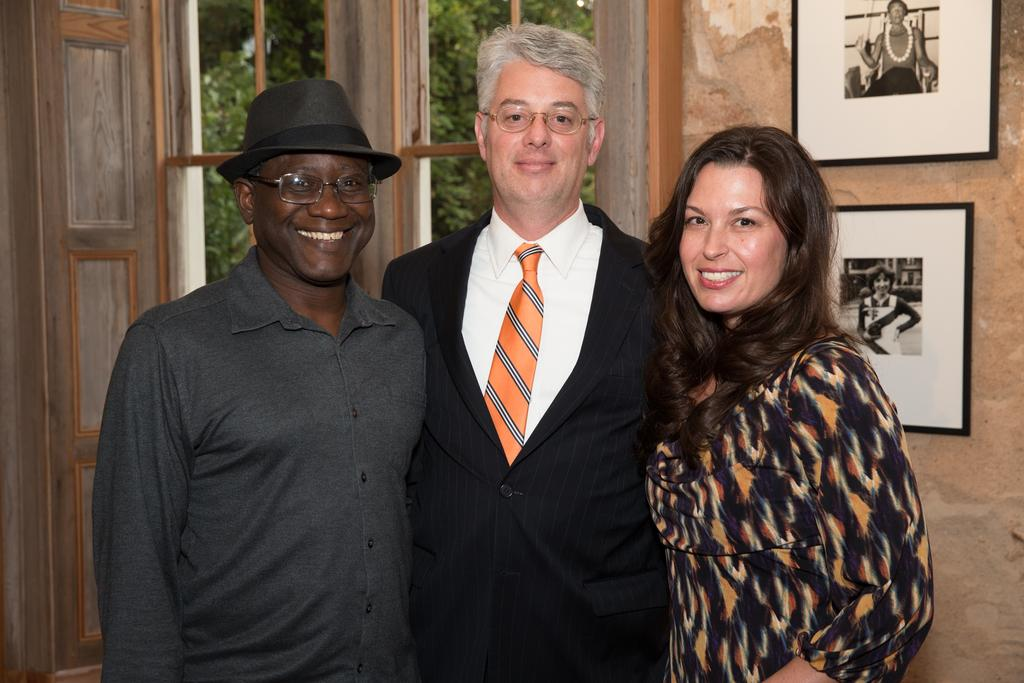How many people are in the image? There are three people in the image. What is the facial expression of the people in the image? The people are smiling. What can be seen on the wall behind the people? There are photo frames on the wall behind the people. What is visible through the window in the image? Trees are visible through the window. What type of condition is causing the heat and expansion in the image? There is no mention of heat or expansion in the image; it features three smiling people with photo frames on the wall and trees visible through a window. 